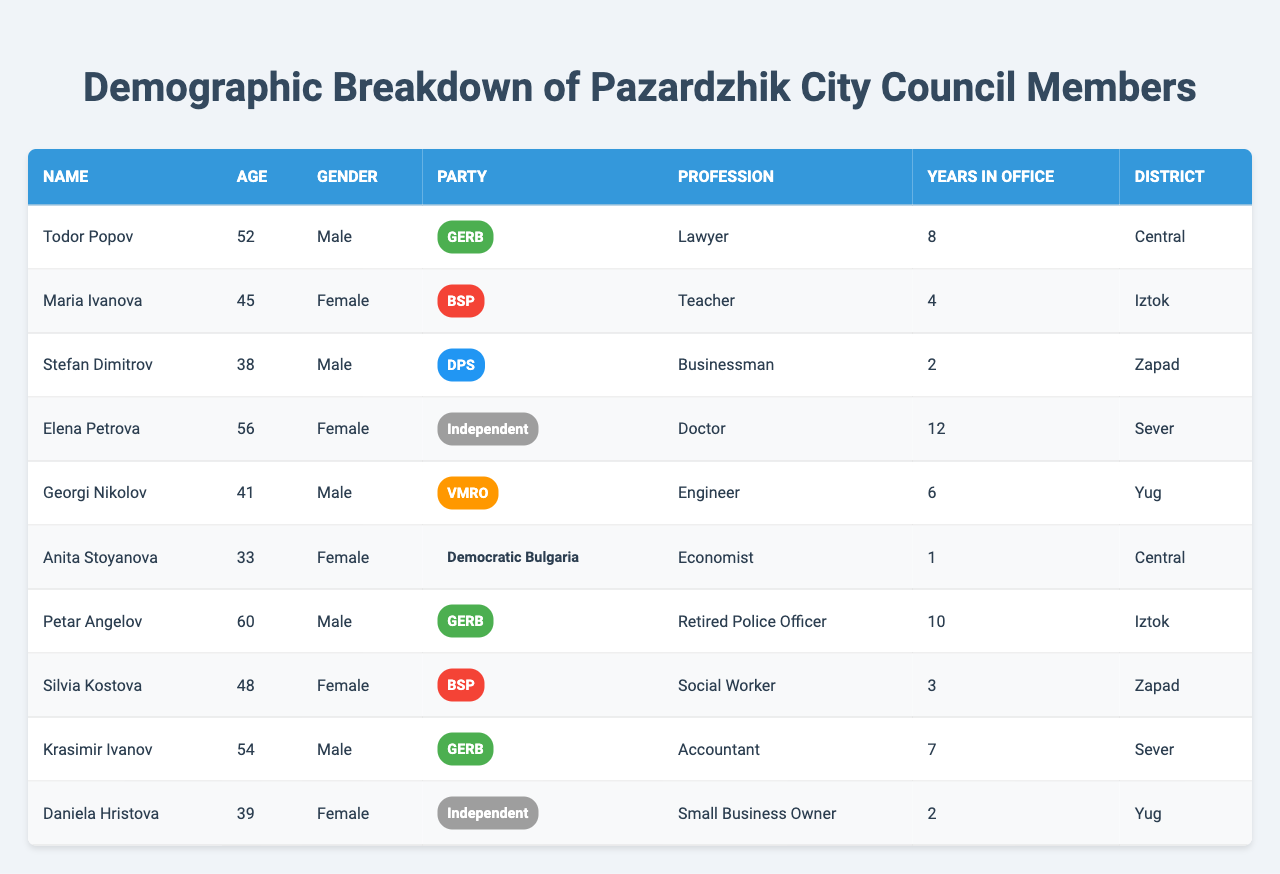What is the name of the youngest council member? The youngest council member listed in the table is Anita Stoyanova, who is 33 years old.
Answer: Anita Stoyanova How many council members belong to the GERB party? There are three members associated with the GERB party, as seen in the table.
Answer: 3 Which district has the highest representation in the council, based on the table? The "Central" district has two representatives, which is the highest among all listed districts.
Answer: Central What is the average age of all council members? To find the average age, we sum the ages (52 + 45 + 38 + 56 + 41 + 33 + 60 + 48 + 54 + 39) = 466, and since there are 10 members, we divide 466 by 10 to get 46.6.
Answer: 46.6 Is there a female council member in the Independent party? Yes, Elena Petrova is a female council member representing the Independent party.
Answer: Yes Which profession is most common among the council members? The professions listed include Lawyer, Teacher, Businessman, Doctor, Engineer, Economist, Retired Police Officer, Social Worker, and Small Business Owner. There is no repeated profession, so no single profession is most common.
Answer: No common profession How many members have served more than five years in office? Todor Popov (8 years), Petar Angelov (10 years), and Elena Petrova (12 years) have all served more than five years, totaling three members.
Answer: 3 What percentage of council members belong to the BSP party? To find the percentage, we note that there are two members from the BSP party out of a total of ten members. Thus, the percentage is (2/10) * 100 = 20%.
Answer: 20% Are there any council members under 40 years old? Yes, Anita Stoyanova is under 40 years old at 33.
Answer: Yes Who has the longest tenure in office, according to the table? The longest tenure in office is held by Elena Petrova, who has served for 12 years.
Answer: Elena Petrova 